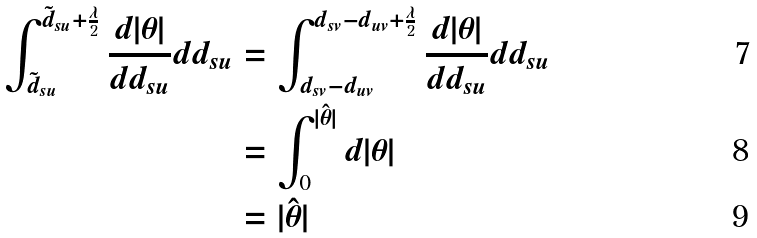<formula> <loc_0><loc_0><loc_500><loc_500>\int _ { \tilde { d } _ { s u } } ^ { \tilde { d } _ { s u } + \frac { \lambda } { 2 } } \frac { d | \theta | } { d d _ { s u } } d d _ { s u } & = \int _ { d _ { s v } - d _ { u v } } ^ { d _ { s v } - d _ { u v } + \frac { \lambda } { 2 } } \frac { d | \theta | } { d d _ { s u } } d d _ { s u } \\ & = \int _ { 0 } ^ { | \hat { \theta } | } d | \theta | \\ & = | \hat { \theta } |</formula> 